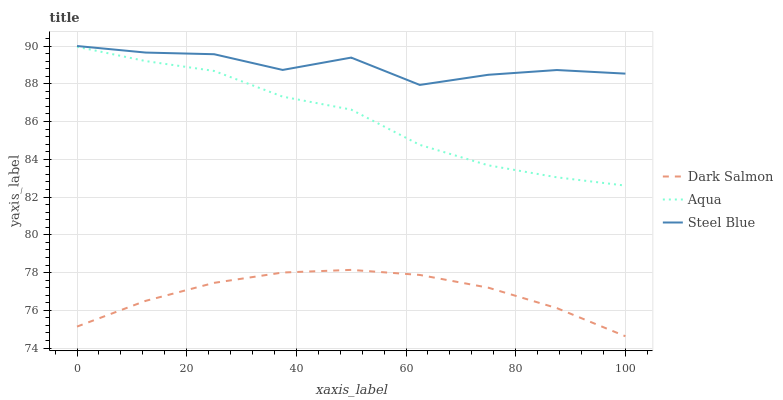Does Dark Salmon have the minimum area under the curve?
Answer yes or no. Yes. Does Steel Blue have the minimum area under the curve?
Answer yes or no. No. Does Dark Salmon have the maximum area under the curve?
Answer yes or no. No. Is Steel Blue the roughest?
Answer yes or no. Yes. Is Steel Blue the smoothest?
Answer yes or no. No. Is Dark Salmon the roughest?
Answer yes or no. No. Does Steel Blue have the lowest value?
Answer yes or no. No. Does Dark Salmon have the highest value?
Answer yes or no. No. Is Aqua less than Steel Blue?
Answer yes or no. Yes. Is Steel Blue greater than Aqua?
Answer yes or no. Yes. Does Aqua intersect Steel Blue?
Answer yes or no. No. 